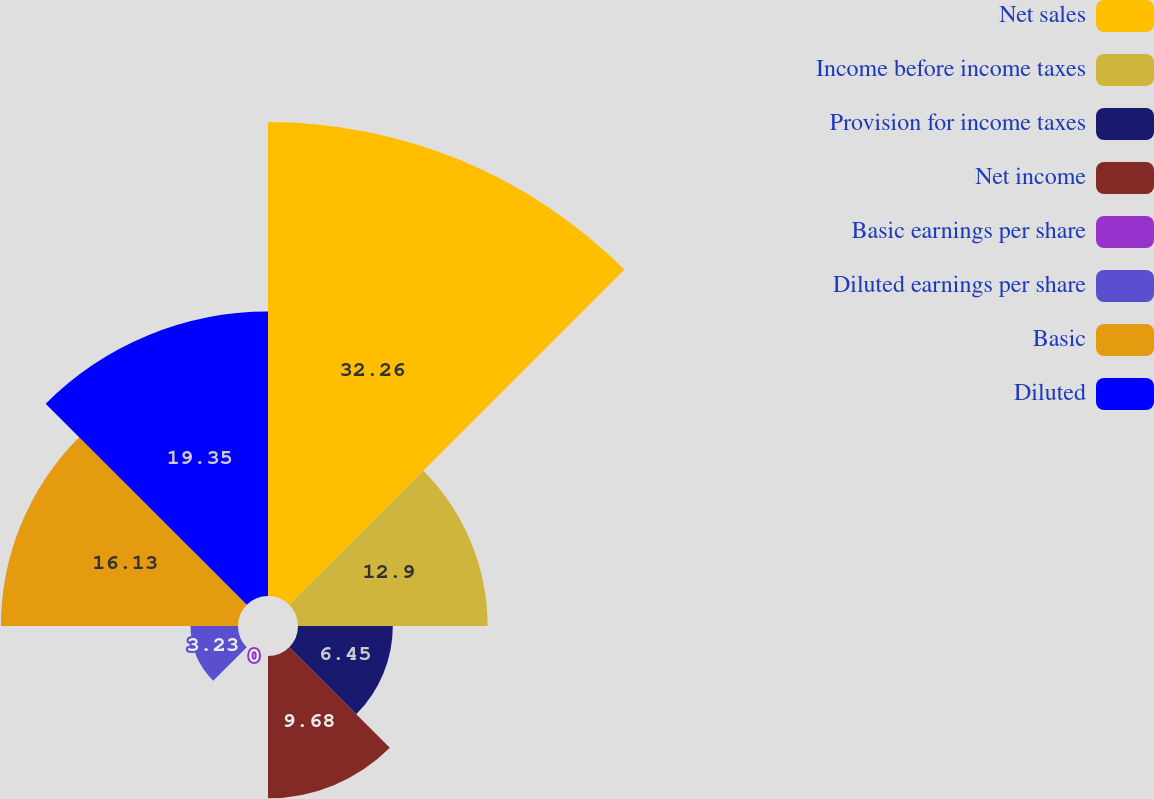<chart> <loc_0><loc_0><loc_500><loc_500><pie_chart><fcel>Net sales<fcel>Income before income taxes<fcel>Provision for income taxes<fcel>Net income<fcel>Basic earnings per share<fcel>Diluted earnings per share<fcel>Basic<fcel>Diluted<nl><fcel>32.25%<fcel>12.9%<fcel>6.45%<fcel>9.68%<fcel>0.0%<fcel>3.23%<fcel>16.13%<fcel>19.35%<nl></chart> 